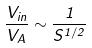<formula> <loc_0><loc_0><loc_500><loc_500>\frac { V _ { i n } } { V _ { A } } \sim \frac { 1 } { S ^ { 1 / 2 } }</formula> 